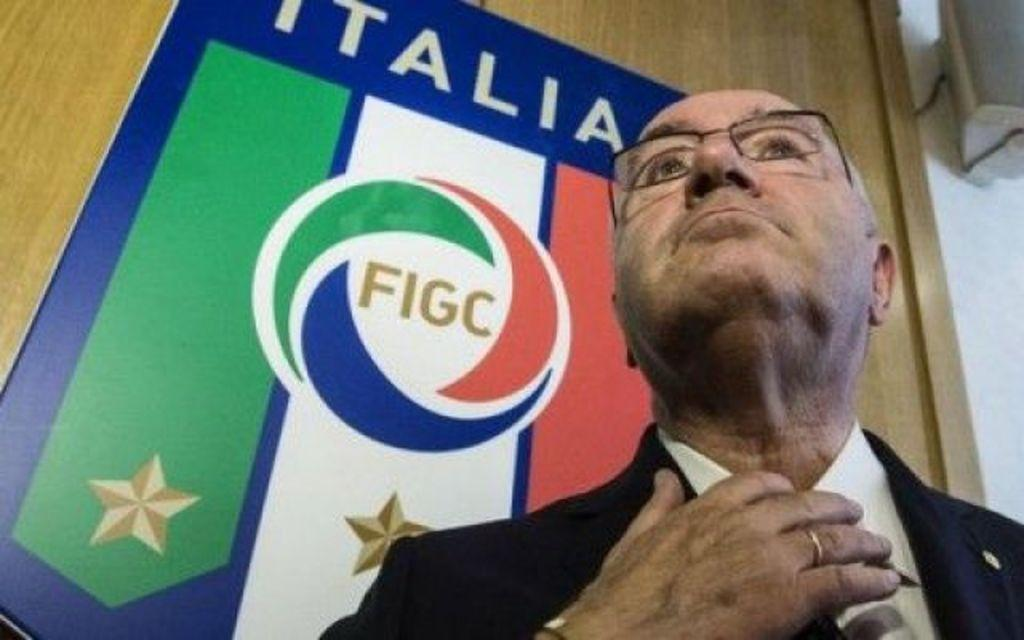Who is present in the image? There is a man in the image. What is the man wearing? The man is wearing a suit and spectacles. What else can be seen in the image besides the man? There is a banner in the image. Can you describe the wooden elements be observed in the image? Yes, the banner is on a wooden background. What type of bulb is hanging from the man's hat in the image? There is no hat or bulb present in the image. How many needles are visible on the man's suit in the image? There are no needles visible on the man's suit in the image. 